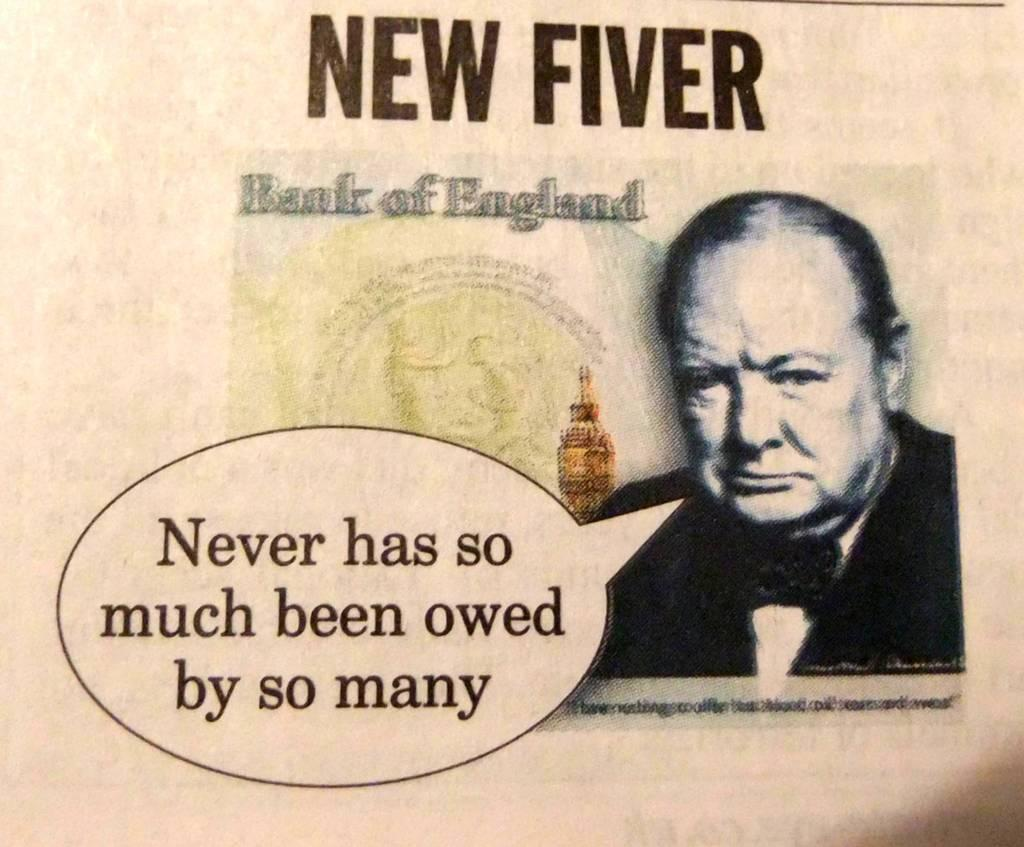What is featured on the poster in the image? There is a poster in the image that contains text and a picture of a person. Are there any other images on the poster besides the person? Yes, the poster includes pictures of other objects. What type of acoustics can be heard from the poster in the image? There are no sounds or acoustics associated with the poster in the image. Can you see a bell on the poster in the image? There is no bell present on the poster in the image. 